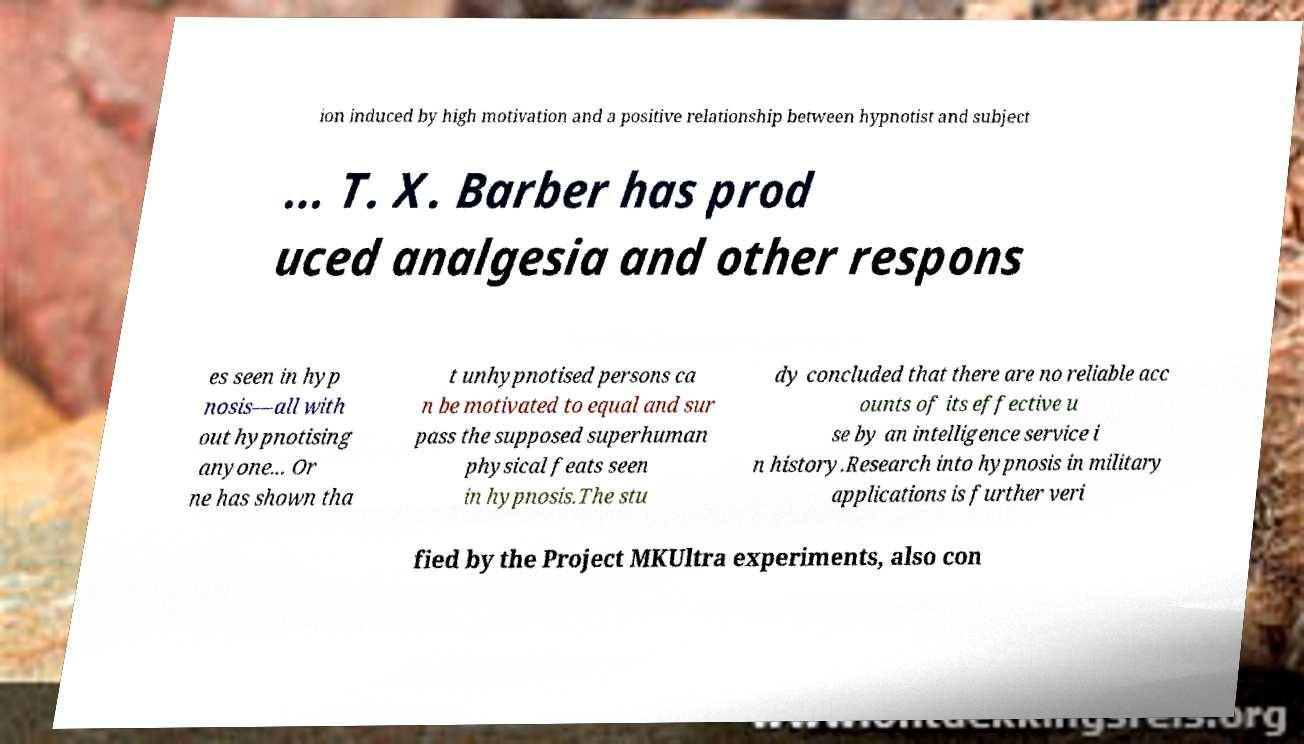I need the written content from this picture converted into text. Can you do that? ion induced by high motivation and a positive relationship between hypnotist and subject ... T. X. Barber has prod uced analgesia and other respons es seen in hyp nosis—all with out hypnotising anyone... Or ne has shown tha t unhypnotised persons ca n be motivated to equal and sur pass the supposed superhuman physical feats seen in hypnosis.The stu dy concluded that there are no reliable acc ounts of its effective u se by an intelligence service i n history.Research into hypnosis in military applications is further veri fied by the Project MKUltra experiments, also con 